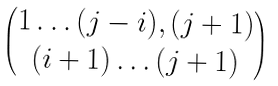Convert formula to latex. <formula><loc_0><loc_0><loc_500><loc_500>\begin{pmatrix} 1 \dots ( j - i ) , ( j + 1 ) \\ ( i + 1 ) \dots ( j + 1 ) \end{pmatrix}</formula> 